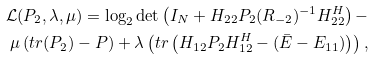Convert formula to latex. <formula><loc_0><loc_0><loc_500><loc_500>\mathcal { L } ( { P } _ { 2 } , \lambda , \mu ) = { \log } _ { 2 } \det \left ( { I } _ { N } + { H } _ { 2 2 } { P } _ { 2 } ( { R } _ { - 2 } ) ^ { - 1 } { H } _ { 2 2 } ^ { H } \right ) - \\ \mu \left ( t r { ( { P } _ { 2 } ) - P } \right ) + \lambda \left ( t r \left ( { H } _ { 1 2 } { P } _ { 2 } { H } _ { 1 2 } ^ { H } - ( \bar { E } - E _ { 1 1 } ) \right ) \right ) ,</formula> 